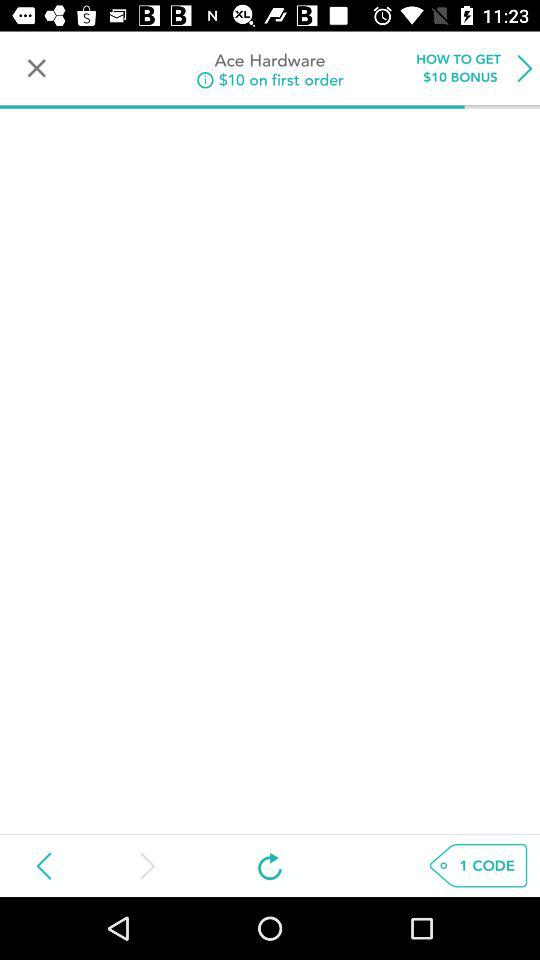What bonus amount will the user get on the first order? The bonus amount that the user will get on the first order is $10. 